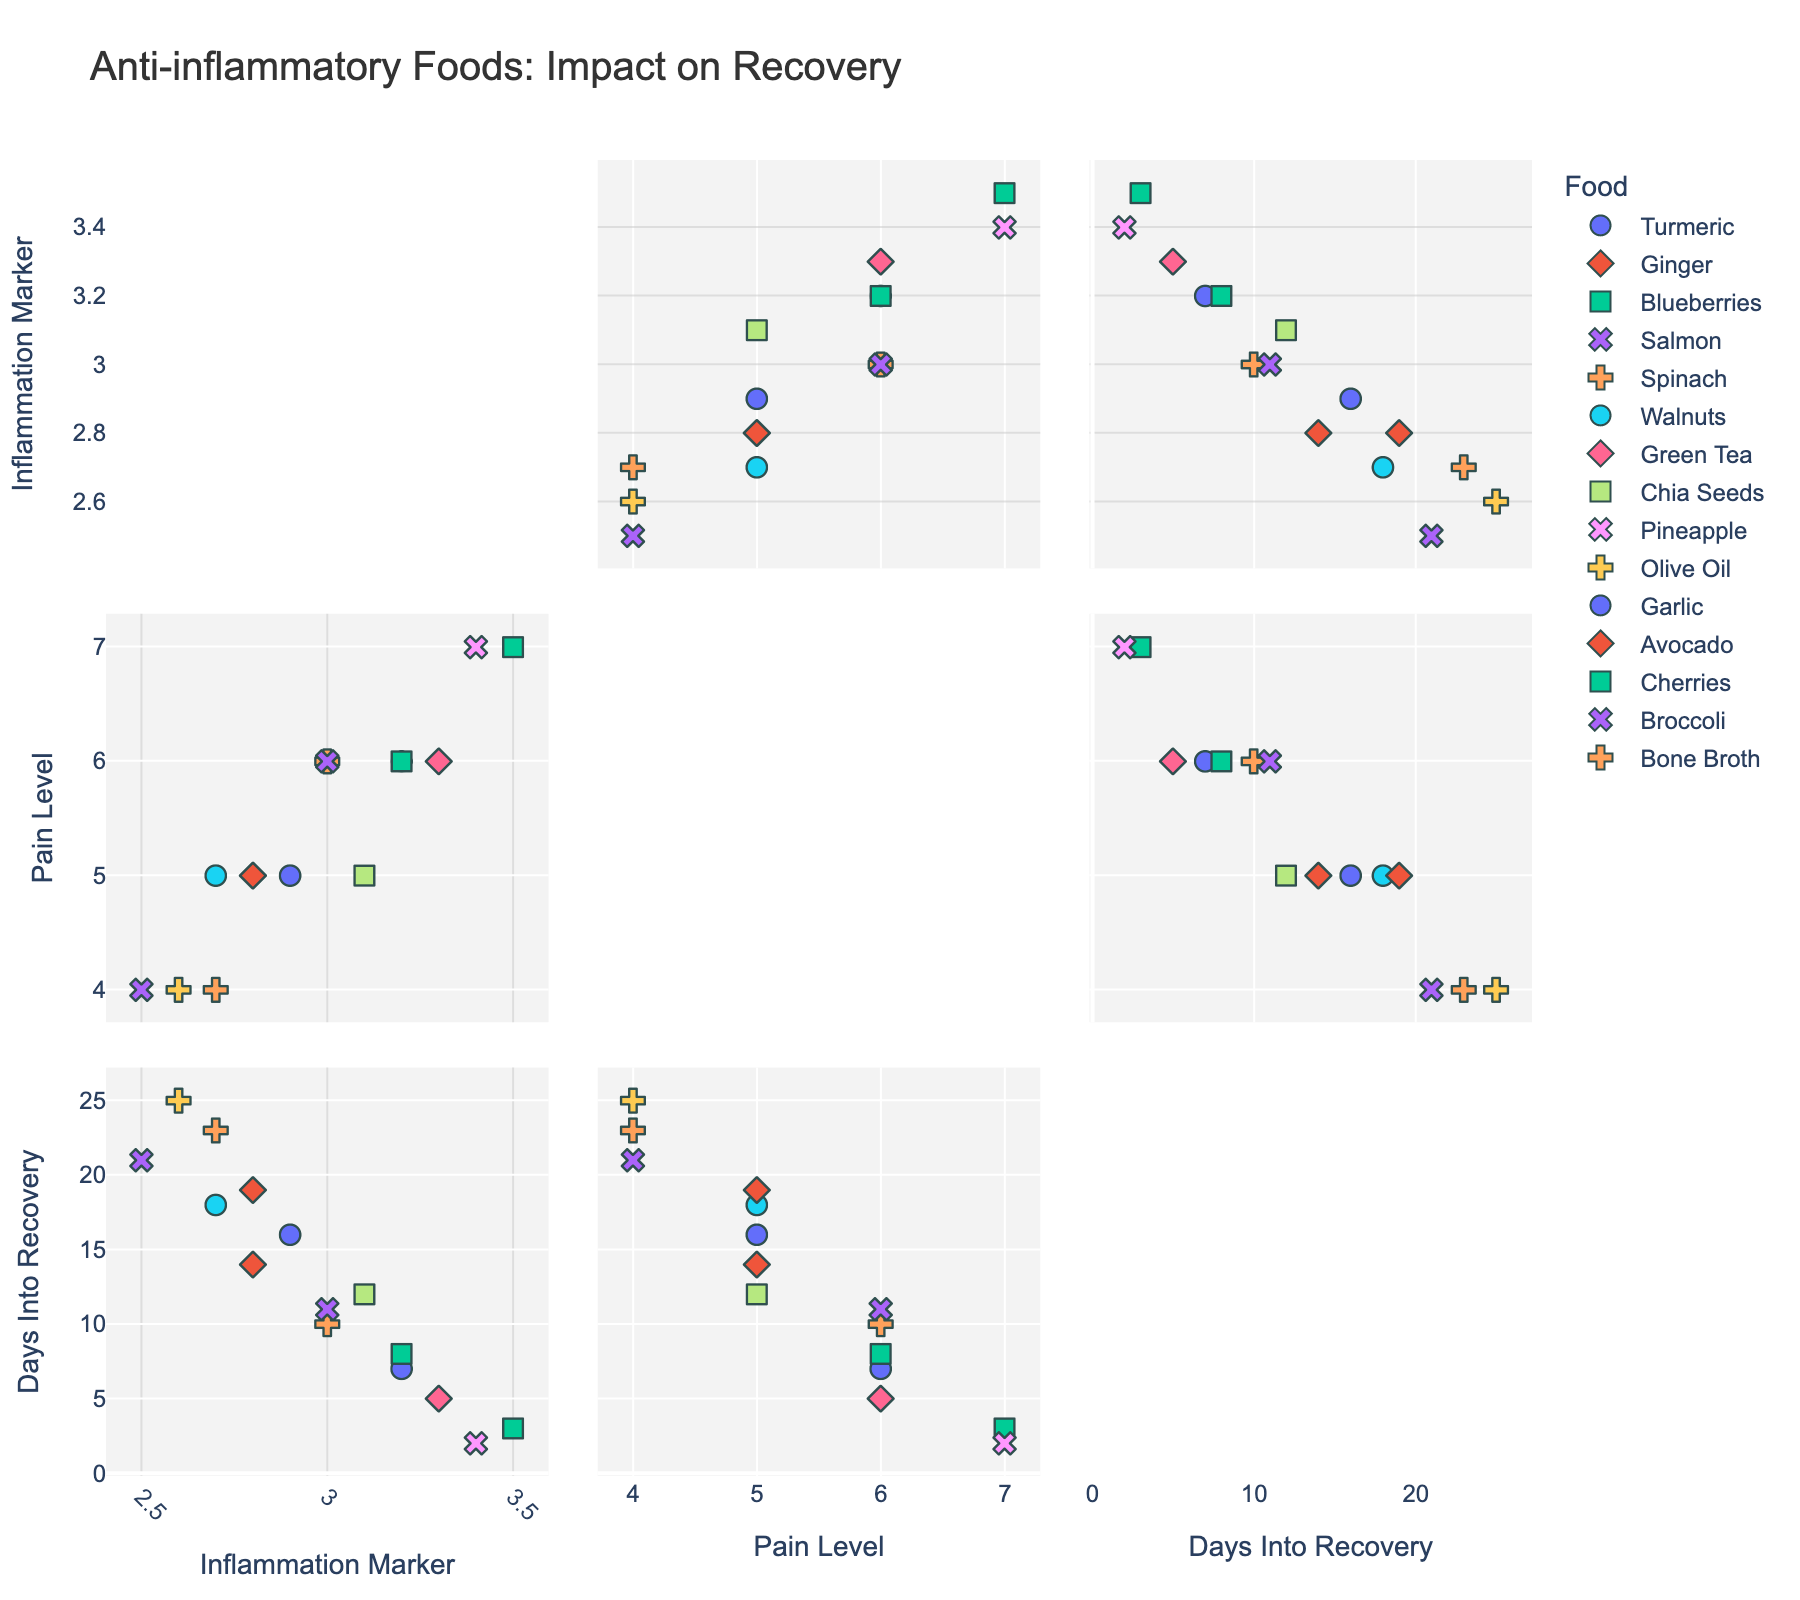What is the title of the figure? The title is usually written at the top of the figure. It is meant to summarize the main topic or focus of the chart.
Answer: "Anti-inflammatory Foods: Impact on Recovery" How many different foods are represented in the scatterplot matrix? By counting the different symbols and colors that represent each unique food item, we can determine the number of different foods.
Answer: 15 Which food has the lowest inflammation marker? By examining the scatterplot for the axis labeled "Inflammation Marker," find the point at the lowest value. The corresponding food is the one associated with that point.
Answer: Salmon What is the median pain level across all foods? First, find the pain levels for all the data points, then sort them numerically. Since there are 15 values, the median is the 8th value in the sorted list.
Answer: 5 Do any foods have the same pain level but different days into recovery? By looking at the scatterplots involving "Pain Level" and "Days Into Recovery," identify any pairs of points that have the same pain level but different days into recovery.
Answer: Yes Which food is associated with the highest pain level? Look at the axis labeled "Pain Level" and find the highest value. Identify the food corresponding to this data point.
Answer: Blueberries Compare the inflammation marker of Bone Broth and Chia Seeds. Which one is higher? Locate the points representing Bone Broth and Chia Seeds on the "Inflammation Marker" axis and compare their values.
Answer: Chia Seeds Are there any foods that have a pain level of 4? If so, which ones? Review the scatterplots and focus on the axis for "Pain Level," specifically at the value 4. Identify the food or foods associated with these points.
Answer: Salmon, Bone Broth What is the average number of days into recovery for foods with a pain level of 5? Identify the points with a pain level of 5, note their "Days Into Recovery" values, and calculate their average. There are 5 foods with pain level 5: Ginger (14), Walnuts (18), Chia Seeds (12), Garlic (16), and Avocado (19). The average is (14+18+12+16+19)/5.
Answer: 15.8 